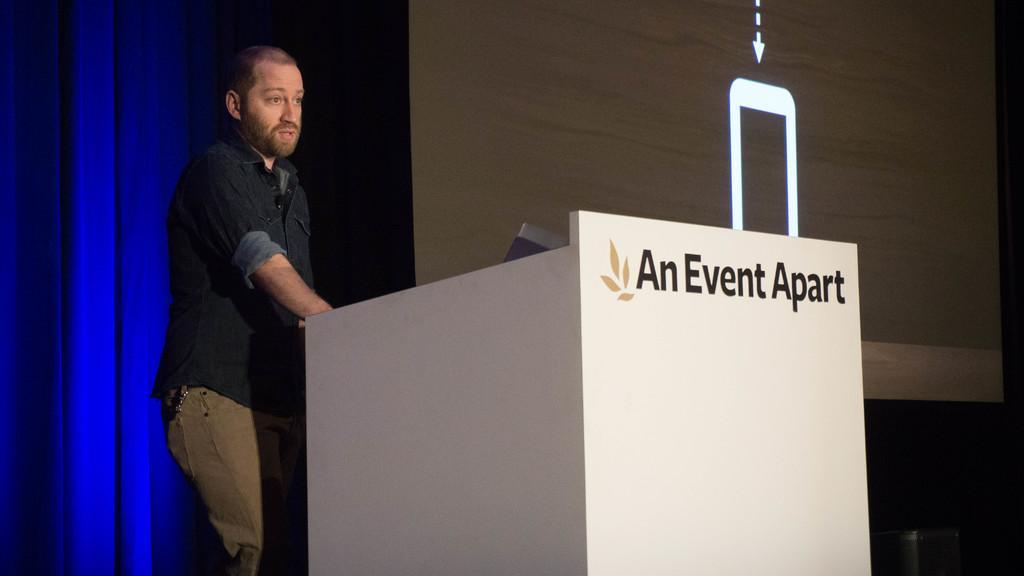Describe this image in one or two sentences. On the left side a man is standing near the podium and talking, he wore shirt, trouser. On the right side it is a projector screen. 